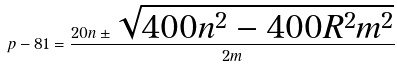Convert formula to latex. <formula><loc_0><loc_0><loc_500><loc_500>p - 8 1 = \frac { 2 0 n \pm \sqrt { 4 0 0 n ^ { 2 } - 4 0 0 R ^ { 2 } m ^ { 2 } } } { 2 m }</formula> 